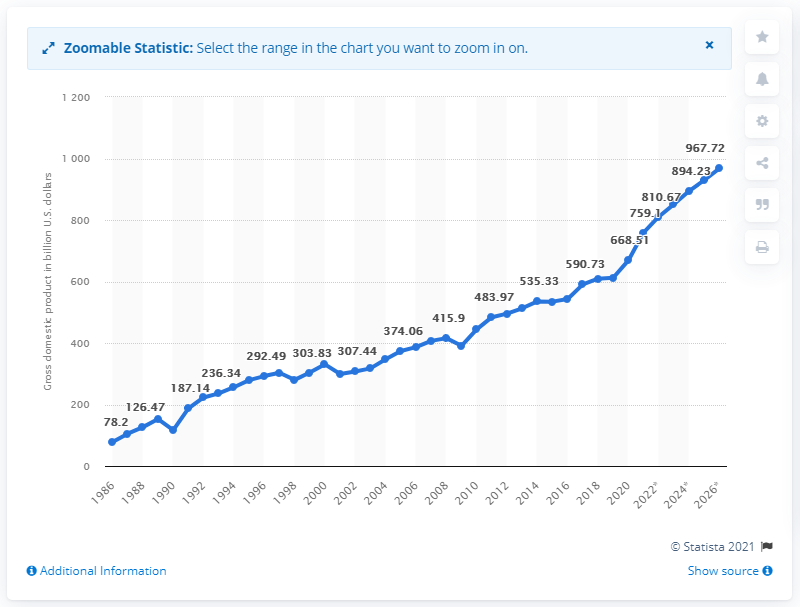Draw attention to some important aspects in this diagram. According to projections, Taiwan's GDP is expected to reach 967.72 by 2026. In 2020, the gross domestic product of Taiwan was approximately 668.51 billion dollars. 